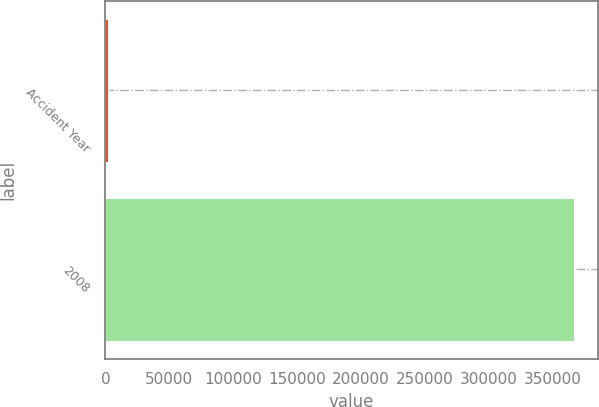Convert chart to OTSL. <chart><loc_0><loc_0><loc_500><loc_500><bar_chart><fcel>Accident Year<fcel>2008<nl><fcel>2016<fcel>366953<nl></chart> 